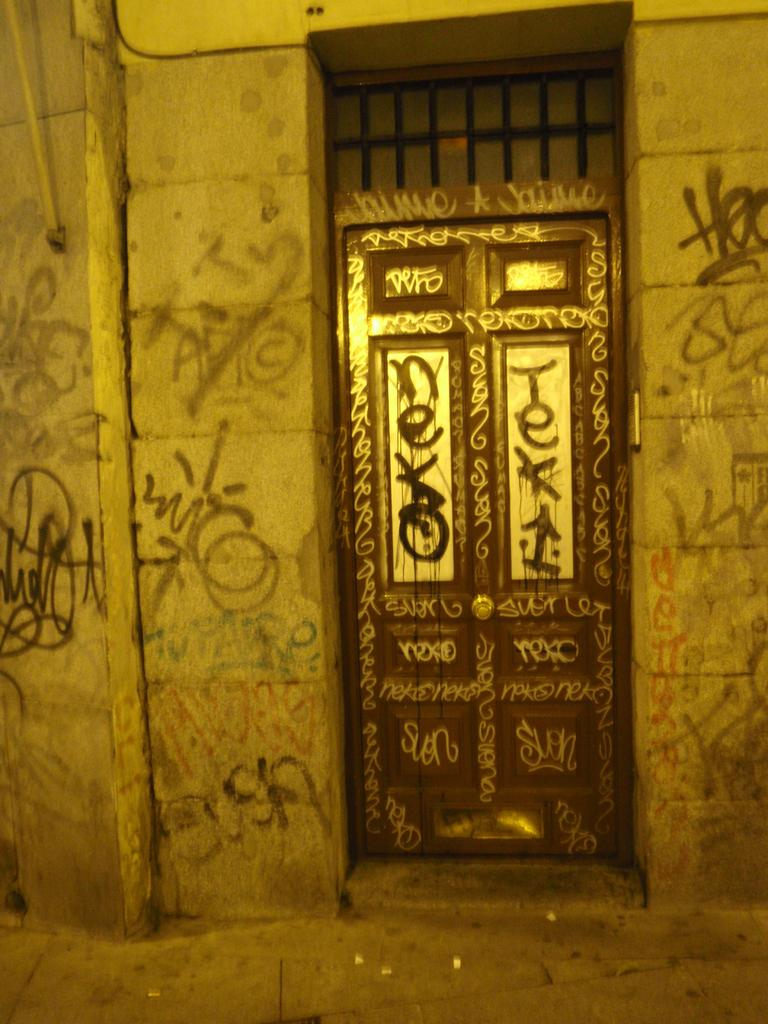What type of door is visible in the image? There is a closed wooden door in the image. What is above the door? There is a window with grill rods above the door. Is there any text visible in the image? Yes, there is some text written on the wall beside the door. What type of apparatus is used to clean the dirt off the trail in the image? There is no apparatus, dirt, or trail present in the image. 